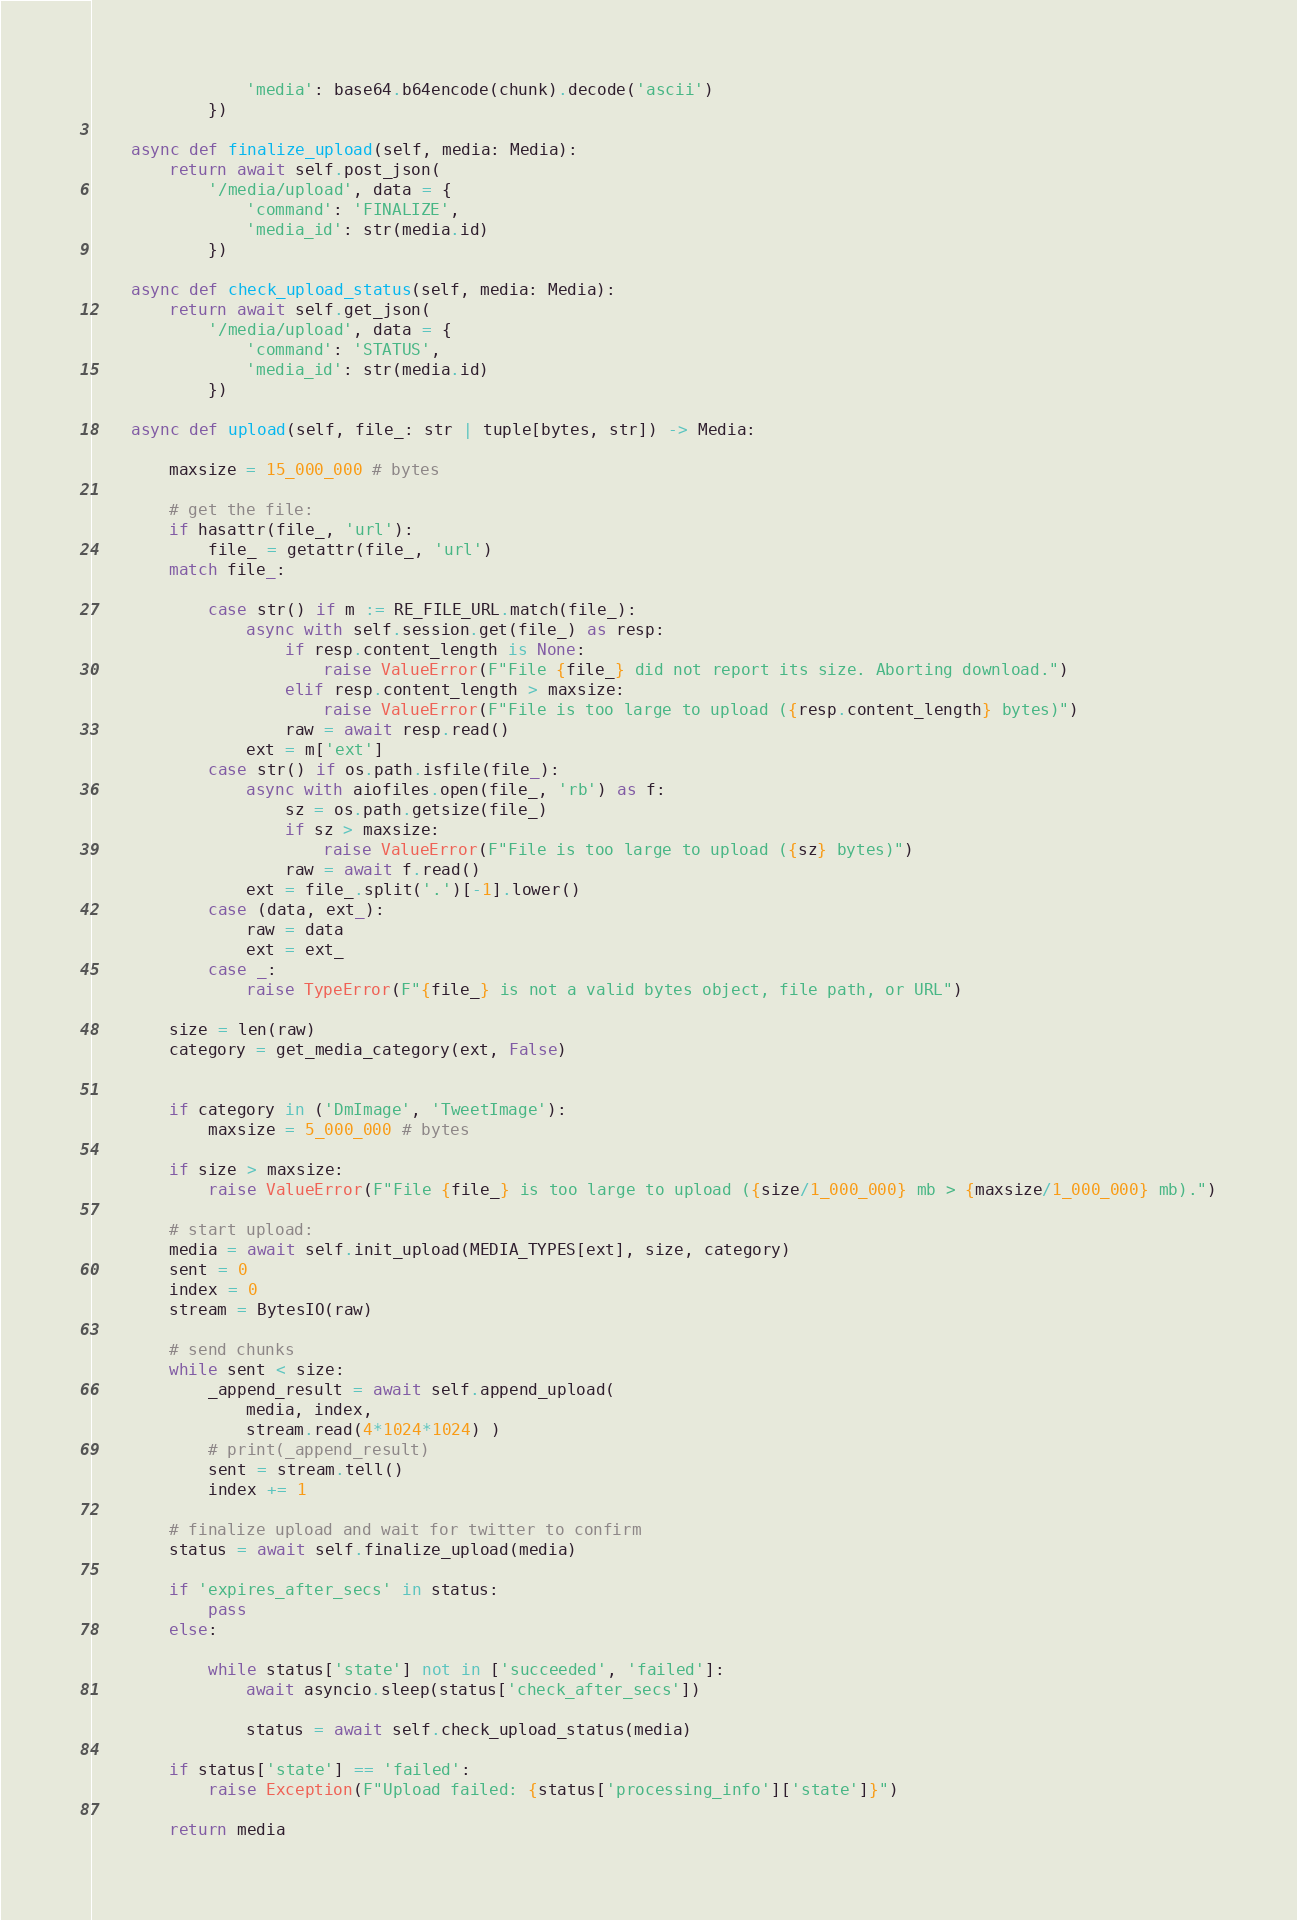Convert code to text. <code><loc_0><loc_0><loc_500><loc_500><_Python_>                'media': base64.b64encode(chunk).decode('ascii')
            })

    async def finalize_upload(self, media: Media):
        return await self.post_json(
            '/media/upload', data = {
                'command': 'FINALIZE',
                'media_id': str(media.id)
            })

    async def check_upload_status(self, media: Media):
        return await self.get_json(
            '/media/upload', data = {
                'command': 'STATUS',
                'media_id': str(media.id)
            })

    async def upload(self, file_: str | tuple[bytes, str]) -> Media:

        maxsize = 15_000_000 # bytes 

        # get the file:
        if hasattr(file_, 'url'):
            file_ = getattr(file_, 'url')
        match file_:
            
            case str() if m := RE_FILE_URL.match(file_):
                async with self.session.get(file_) as resp:
                    if resp.content_length is None:
                        raise ValueError(F"File {file_} did not report its size. Aborting download.")
                    elif resp.content_length > maxsize:
                        raise ValueError(F"File is too large to upload ({resp.content_length} bytes)")
                    raw = await resp.read()
                ext = m['ext']
            case str() if os.path.isfile(file_):
                async with aiofiles.open(file_, 'rb') as f:
                    sz = os.path.getsize(file_)
                    if sz > maxsize:
                        raise ValueError(F"File is too large to upload ({sz} bytes)")
                    raw = await f.read()
                ext = file_.split('.')[-1].lower()
            case (data, ext_):
                raw = data
                ext = ext_
            case _:
                raise TypeError(F"{file_} is not a valid bytes object, file path, or URL")

        size = len(raw)
        category = get_media_category(ext, False)

        
        if category in ('DmImage', 'TweetImage'):
            maxsize = 5_000_000 # bytes

        if size > maxsize:
            raise ValueError(F"File {file_} is too large to upload ({size/1_000_000} mb > {maxsize/1_000_000} mb).")

        # start upload:
        media = await self.init_upload(MEDIA_TYPES[ext], size, category)
        sent = 0
        index = 0
        stream = BytesIO(raw)

        # send chunks
        while sent < size:
            _append_result = await self.append_upload(
                media, index,
                stream.read(4*1024*1024) )
            # print(_append_result)
            sent = stream.tell()
            index += 1
        
        # finalize upload and wait for twitter to confirm
        status = await self.finalize_upload(media)

        if 'expires_after_secs' in status:
            pass
        else:

            while status['state'] not in ['succeeded', 'failed']:
                await asyncio.sleep(status['check_after_secs'])

                status = await self.check_upload_status(media)

        if status['state'] == 'failed':
            raise Exception(F"Upload failed: {status['processing_info']['state']}")

        return media</code> 